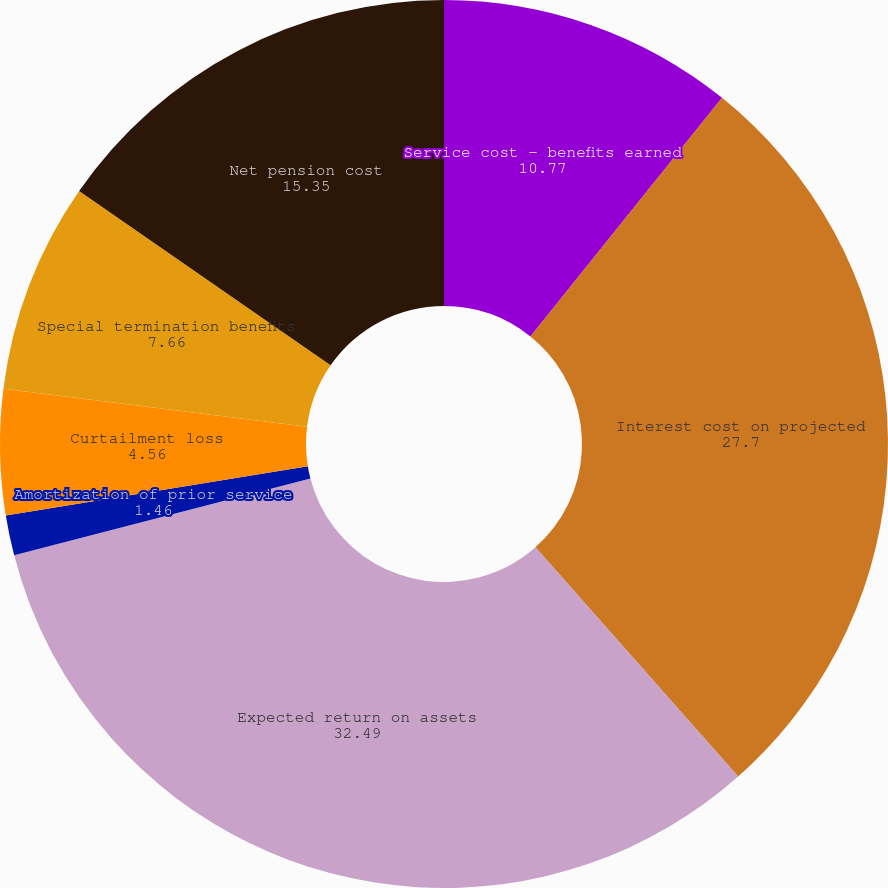Convert chart. <chart><loc_0><loc_0><loc_500><loc_500><pie_chart><fcel>Service cost - benefits earned<fcel>Interest cost on projected<fcel>Expected return on assets<fcel>Amortization of prior service<fcel>Curtailment loss<fcel>Special termination benefits<fcel>Net pension cost<nl><fcel>10.77%<fcel>27.7%<fcel>32.49%<fcel>1.46%<fcel>4.56%<fcel>7.66%<fcel>15.35%<nl></chart> 